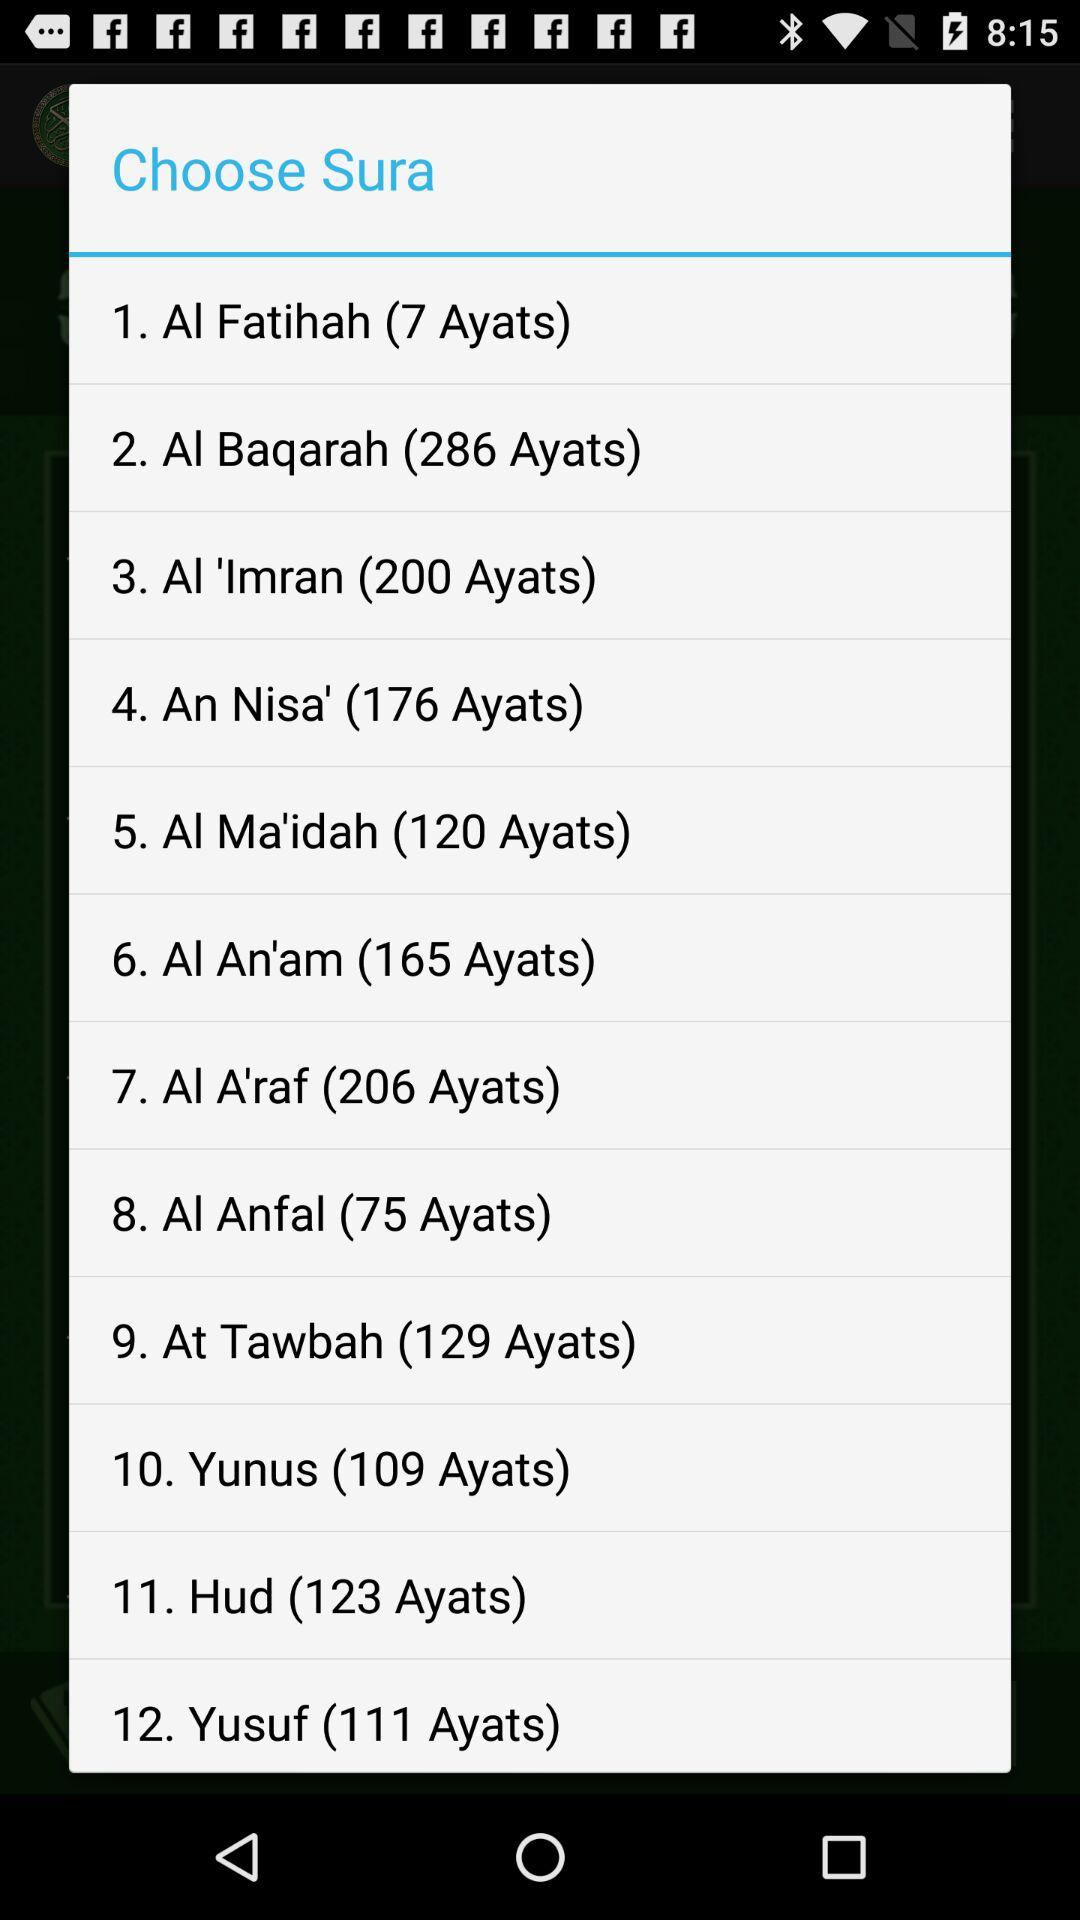How many ayats are there in "At Tawbah"? There are 129 ayats in "At Tawbah". 